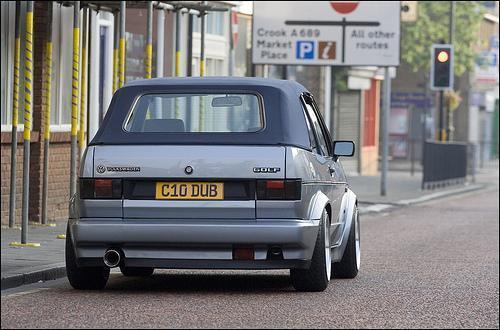How many trees are behind a traffic light?
Give a very brief answer. 1. 